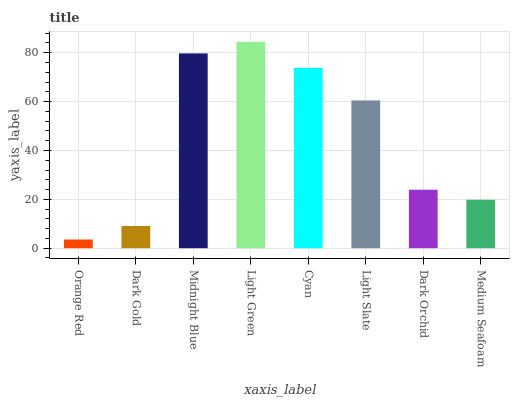Is Dark Gold the minimum?
Answer yes or no. No. Is Dark Gold the maximum?
Answer yes or no. No. Is Dark Gold greater than Orange Red?
Answer yes or no. Yes. Is Orange Red less than Dark Gold?
Answer yes or no. Yes. Is Orange Red greater than Dark Gold?
Answer yes or no. No. Is Dark Gold less than Orange Red?
Answer yes or no. No. Is Light Slate the high median?
Answer yes or no. Yes. Is Dark Orchid the low median?
Answer yes or no. Yes. Is Midnight Blue the high median?
Answer yes or no. No. Is Medium Seafoam the low median?
Answer yes or no. No. 